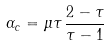Convert formula to latex. <formula><loc_0><loc_0><loc_500><loc_500>\alpha _ { c } = \mu \tau \, \frac { 2 - \tau } { \tau - 1 }</formula> 